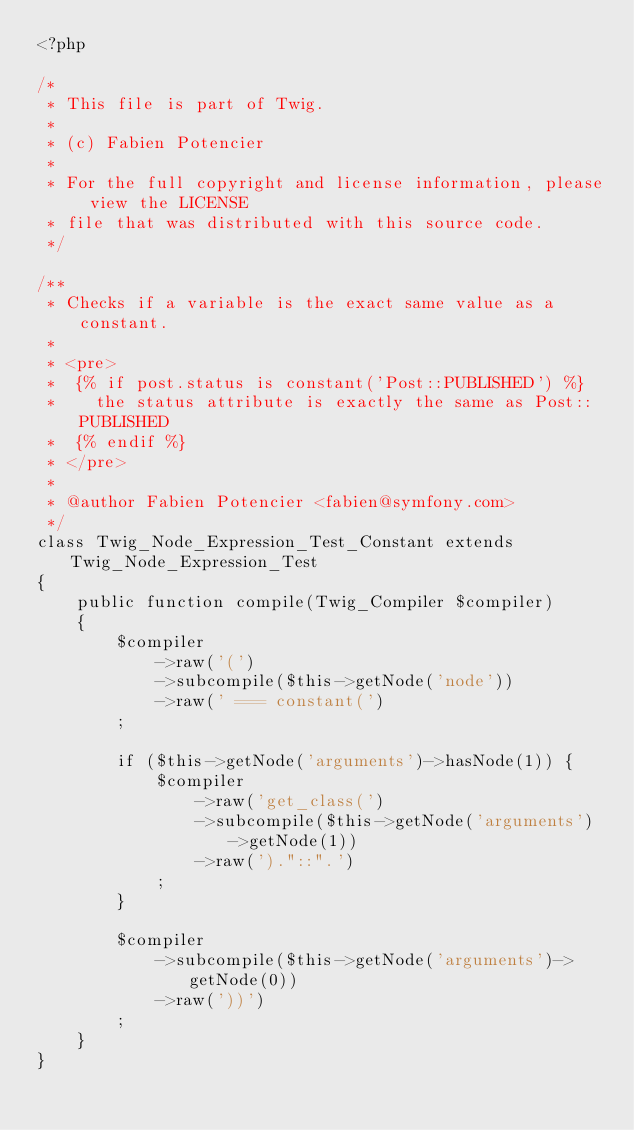Convert code to text. <code><loc_0><loc_0><loc_500><loc_500><_PHP_><?php

/*
 * This file is part of Twig.
 *
 * (c) Fabien Potencier
 *
 * For the full copyright and license information, please view the LICENSE
 * file that was distributed with this source code.
 */

/**
 * Checks if a variable is the exact same value as a constant.
 *
 * <pre>
 *  {% if post.status is constant('Post::PUBLISHED') %}
 *    the status attribute is exactly the same as Post::PUBLISHED
 *  {% endif %}
 * </pre>
 *
 * @author Fabien Potencier <fabien@symfony.com>
 */
class Twig_Node_Expression_Test_Constant extends Twig_Node_Expression_Test
{
    public function compile(Twig_Compiler $compiler)
    {
        $compiler
            ->raw('(')
            ->subcompile($this->getNode('node'))
            ->raw(' === constant(')
        ;

        if ($this->getNode('arguments')->hasNode(1)) {
            $compiler
                ->raw('get_class(')
                ->subcompile($this->getNode('arguments')->getNode(1))
                ->raw(')."::".')
            ;
        }

        $compiler
            ->subcompile($this->getNode('arguments')->getNode(0))
            ->raw('))')
        ;
    }
}
</code> 